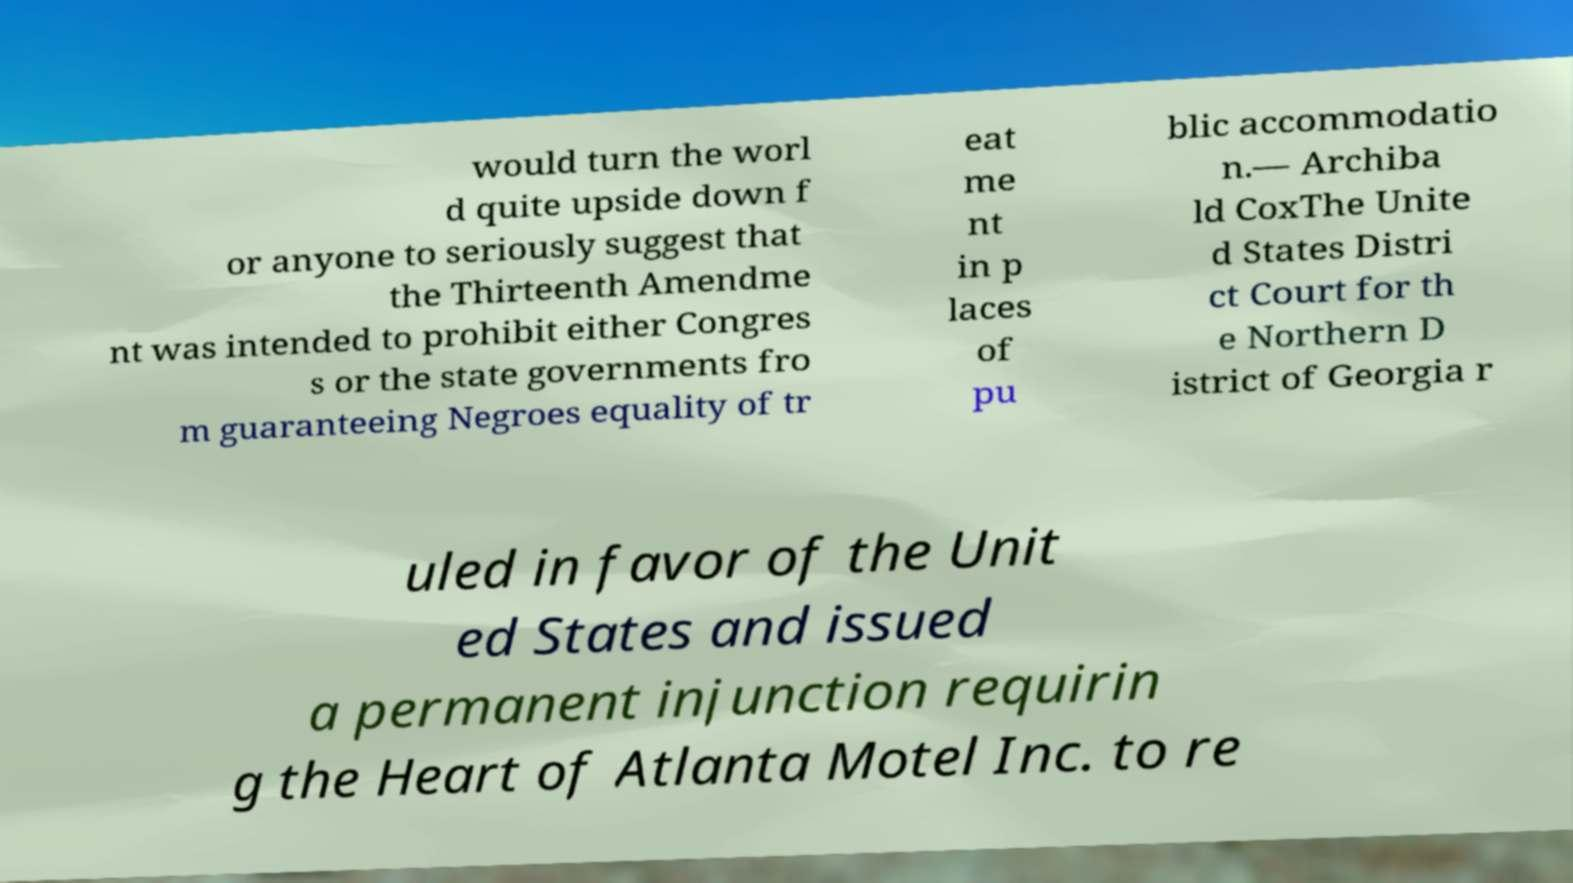Please identify and transcribe the text found in this image. would turn the worl d quite upside down f or anyone to seriously suggest that the Thirteenth Amendme nt was intended to prohibit either Congres s or the state governments fro m guaranteeing Negroes equality of tr eat me nt in p laces of pu blic accommodatio n.— Archiba ld CoxThe Unite d States Distri ct Court for th e Northern D istrict of Georgia r uled in favor of the Unit ed States and issued a permanent injunction requirin g the Heart of Atlanta Motel Inc. to re 